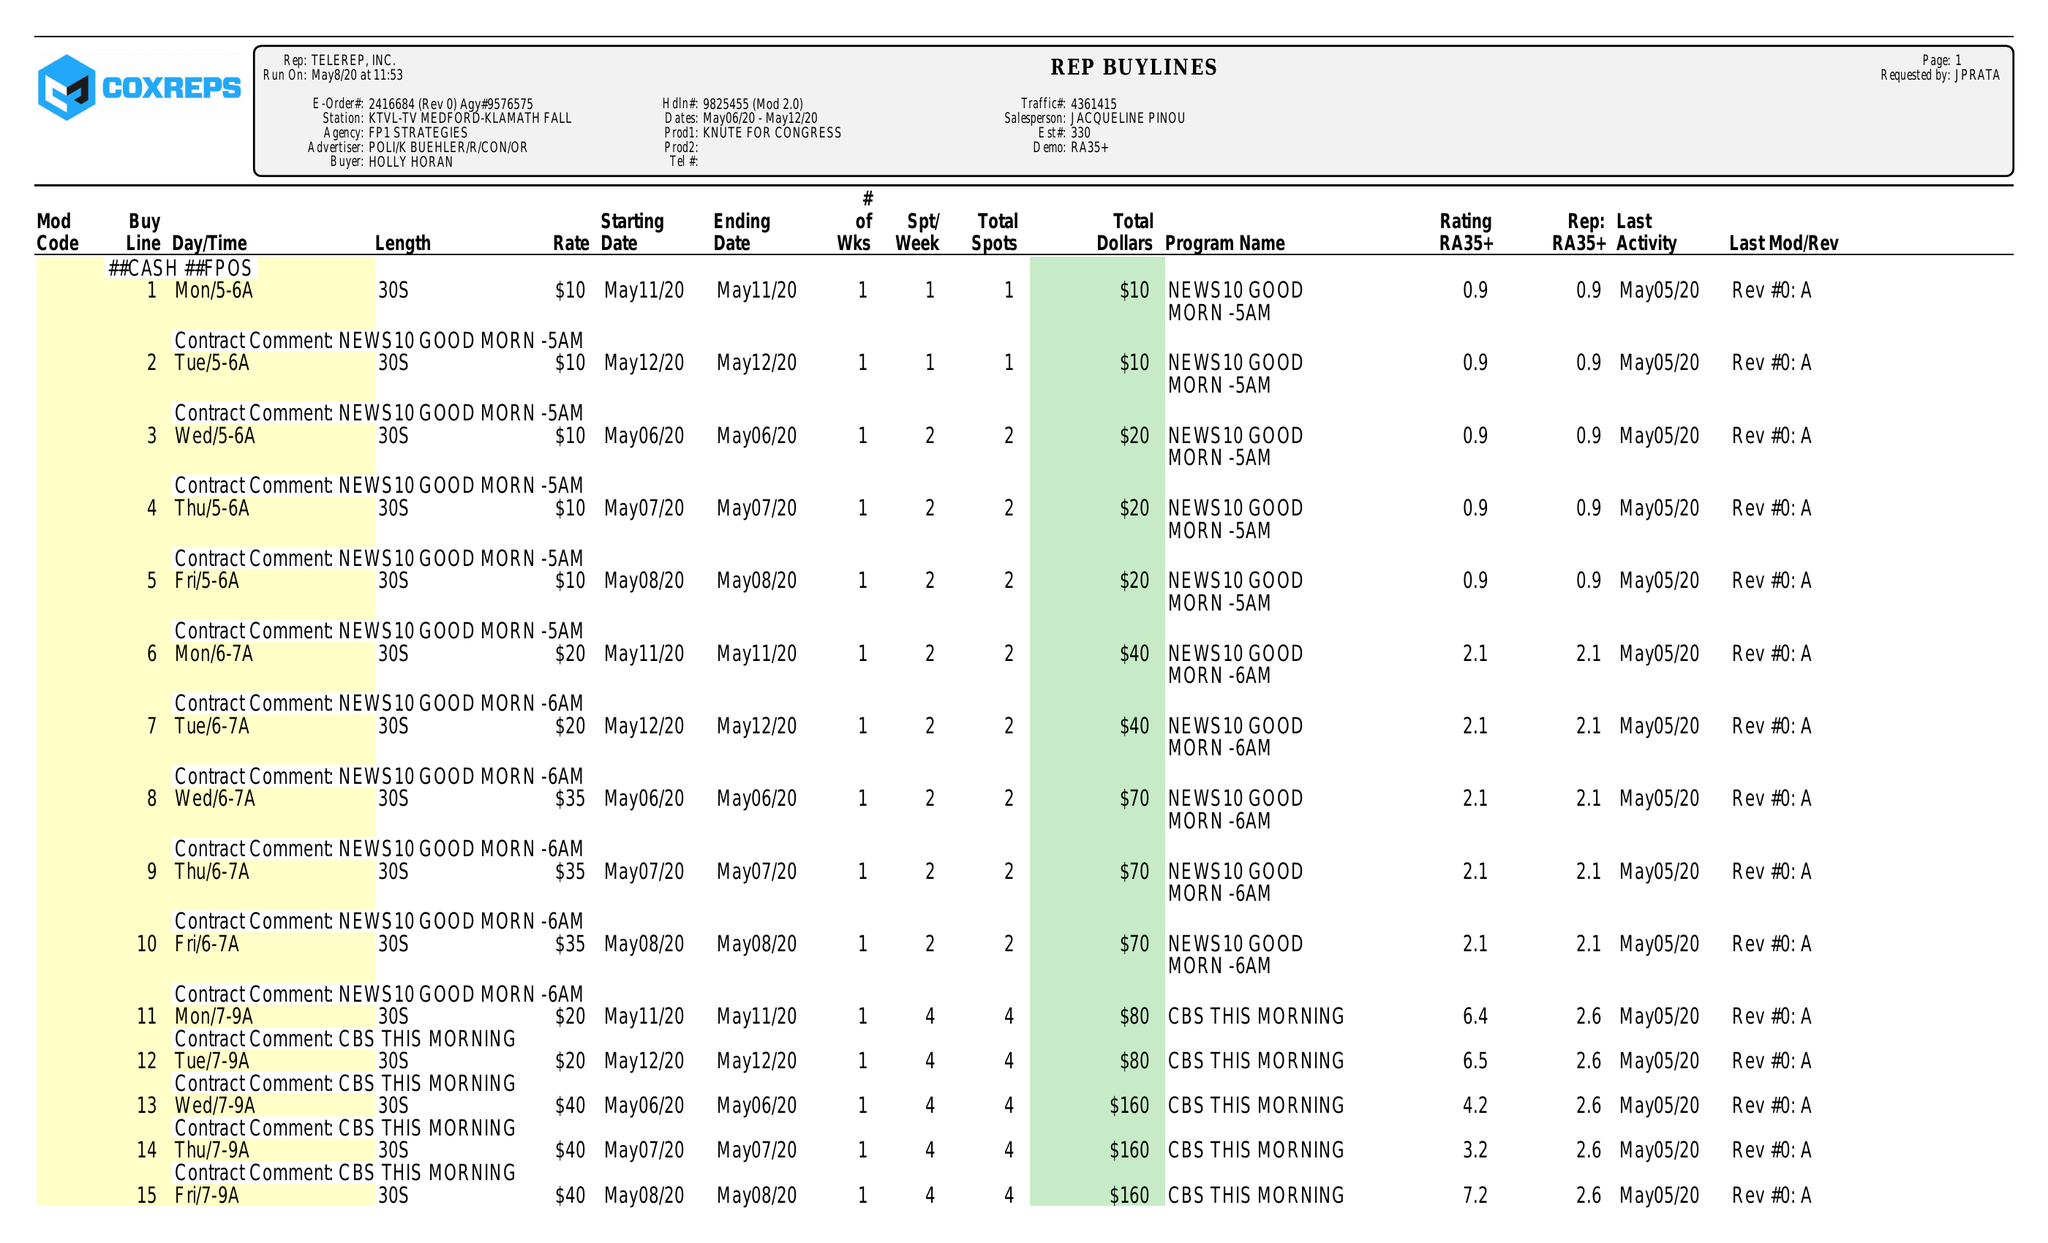What is the value for the contract_num?
Answer the question using a single word or phrase. 2416684 